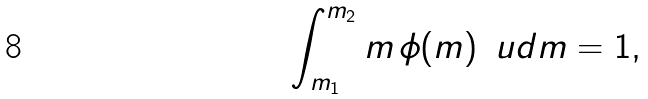<formula> <loc_0><loc_0><loc_500><loc_500>\int _ { m _ { 1 } } ^ { m _ { 2 } } m \, \phi ( m ) \, \ u d m = 1 ,</formula> 